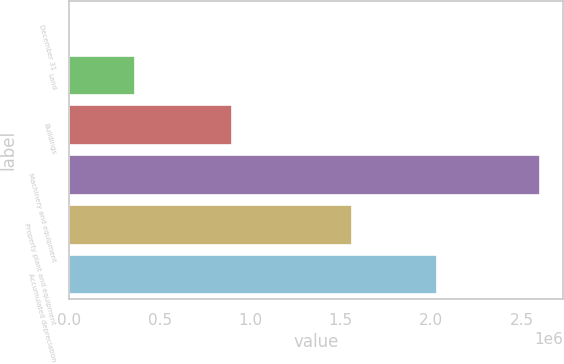Convert chart. <chart><loc_0><loc_0><loc_500><loc_500><bar_chart><fcel>December 31<fcel>Land<fcel>Buildings<fcel>Machinery and equipment<fcel>Property plant and equipment<fcel>Accumulated depreciation<nl><fcel>2011<fcel>360666<fcel>895859<fcel>2.6002e+06<fcel>1.55972e+06<fcel>2.02884e+06<nl></chart> 